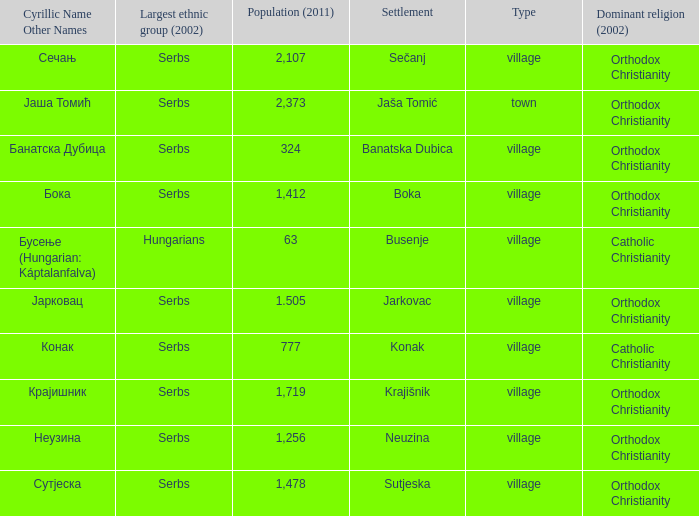The pooulation of јарковац is? 1.505. 